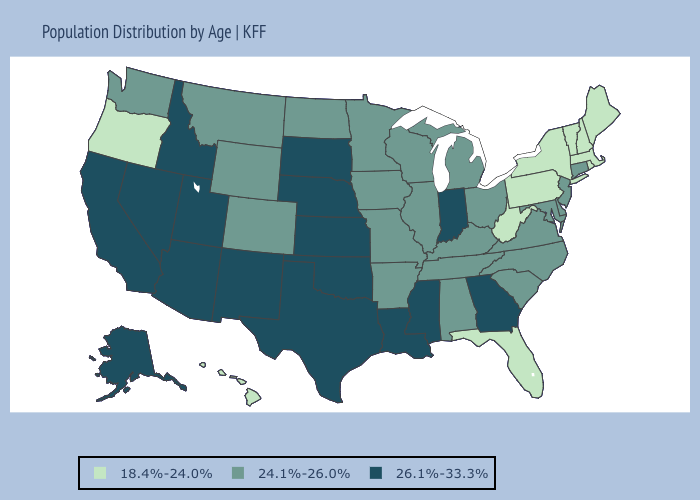What is the value of Florida?
Concise answer only. 18.4%-24.0%. Does Georgia have a higher value than Washington?
Quick response, please. Yes. Name the states that have a value in the range 24.1%-26.0%?
Concise answer only. Alabama, Arkansas, Colorado, Connecticut, Delaware, Illinois, Iowa, Kentucky, Maryland, Michigan, Minnesota, Missouri, Montana, New Jersey, North Carolina, North Dakota, Ohio, South Carolina, Tennessee, Virginia, Washington, Wisconsin, Wyoming. Which states have the lowest value in the Northeast?
Write a very short answer. Maine, Massachusetts, New Hampshire, New York, Pennsylvania, Rhode Island, Vermont. What is the lowest value in states that border New Mexico?
Write a very short answer. 24.1%-26.0%. Does Maine have the same value as North Carolina?
Keep it brief. No. Among the states that border Montana , which have the highest value?
Keep it brief. Idaho, South Dakota. Name the states that have a value in the range 26.1%-33.3%?
Keep it brief. Alaska, Arizona, California, Georgia, Idaho, Indiana, Kansas, Louisiana, Mississippi, Nebraska, Nevada, New Mexico, Oklahoma, South Dakota, Texas, Utah. Among the states that border New Mexico , does Oklahoma have the highest value?
Give a very brief answer. Yes. What is the value of Florida?
Answer briefly. 18.4%-24.0%. Does New Mexico have a higher value than South Carolina?
Be succinct. Yes. What is the highest value in the USA?
Short answer required. 26.1%-33.3%. What is the value of Michigan?
Answer briefly. 24.1%-26.0%. Name the states that have a value in the range 24.1%-26.0%?
Write a very short answer. Alabama, Arkansas, Colorado, Connecticut, Delaware, Illinois, Iowa, Kentucky, Maryland, Michigan, Minnesota, Missouri, Montana, New Jersey, North Carolina, North Dakota, Ohio, South Carolina, Tennessee, Virginia, Washington, Wisconsin, Wyoming. Among the states that border Kansas , which have the lowest value?
Keep it brief. Colorado, Missouri. 